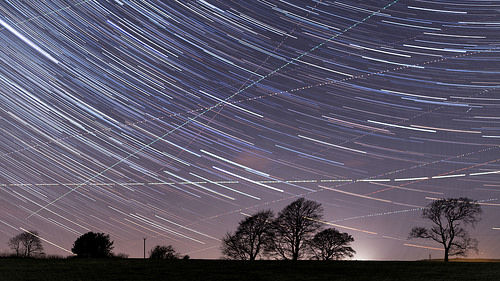<image>
Is the shooting star on the tree? No. The shooting star is not positioned on the tree. They may be near each other, but the shooting star is not supported by or resting on top of the tree. 